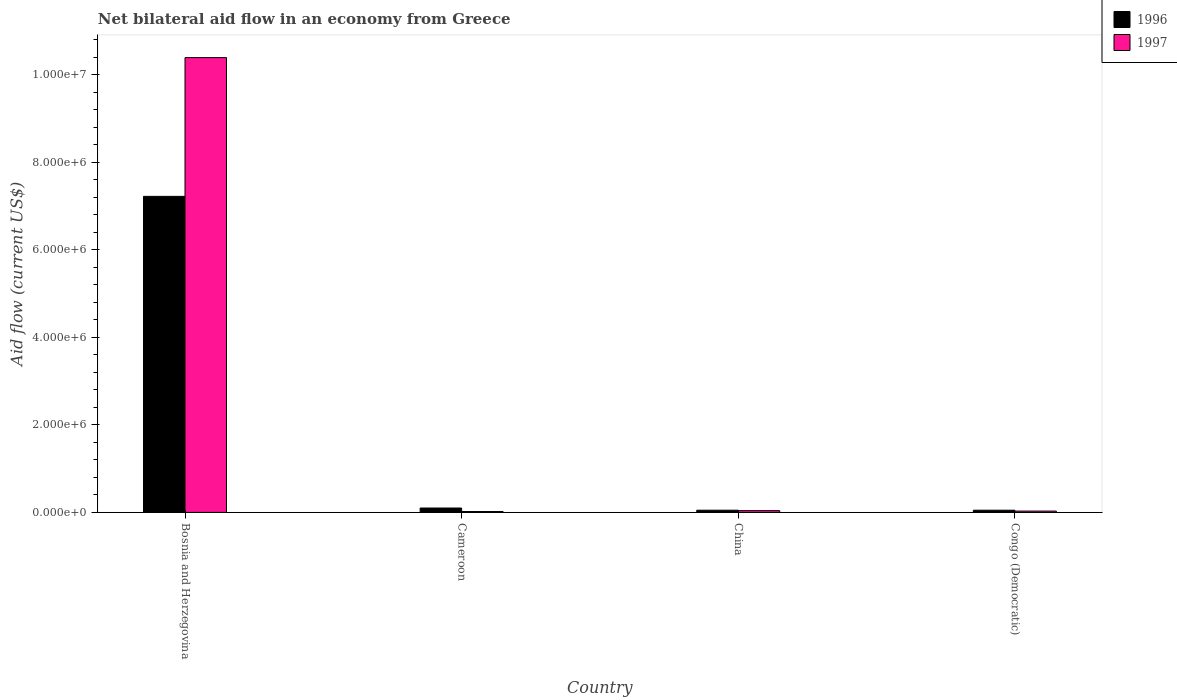How many different coloured bars are there?
Provide a short and direct response. 2. How many groups of bars are there?
Give a very brief answer. 4. How many bars are there on the 1st tick from the left?
Provide a succinct answer. 2. What is the label of the 1st group of bars from the left?
Provide a short and direct response. Bosnia and Herzegovina. What is the net bilateral aid flow in 1996 in China?
Keep it short and to the point. 5.00e+04. Across all countries, what is the maximum net bilateral aid flow in 1996?
Provide a succinct answer. 7.22e+06. In which country was the net bilateral aid flow in 1997 maximum?
Your answer should be compact. Bosnia and Herzegovina. In which country was the net bilateral aid flow in 1997 minimum?
Your answer should be compact. Cameroon. What is the total net bilateral aid flow in 1997 in the graph?
Your answer should be very brief. 1.05e+07. What is the difference between the net bilateral aid flow in 1997 in China and that in Congo (Democratic)?
Your response must be concise. 10000. What is the average net bilateral aid flow in 1997 per country?
Give a very brief answer. 2.62e+06. In how many countries, is the net bilateral aid flow in 1996 greater than 1200000 US$?
Give a very brief answer. 1. What is the ratio of the net bilateral aid flow in 1997 in China to that in Congo (Democratic)?
Offer a very short reply. 1.33. What is the difference between the highest and the second highest net bilateral aid flow in 1997?
Make the answer very short. 1.04e+07. What is the difference between the highest and the lowest net bilateral aid flow in 1997?
Ensure brevity in your answer.  1.04e+07. In how many countries, is the net bilateral aid flow in 1996 greater than the average net bilateral aid flow in 1996 taken over all countries?
Your answer should be compact. 1. Is the sum of the net bilateral aid flow in 1996 in Bosnia and Herzegovina and Cameroon greater than the maximum net bilateral aid flow in 1997 across all countries?
Your answer should be compact. No. What does the 2nd bar from the left in China represents?
Offer a very short reply. 1997. How many bars are there?
Your response must be concise. 8. Are all the bars in the graph horizontal?
Provide a succinct answer. No. How many countries are there in the graph?
Offer a very short reply. 4. Does the graph contain any zero values?
Your response must be concise. No. Where does the legend appear in the graph?
Offer a very short reply. Top right. What is the title of the graph?
Your answer should be compact. Net bilateral aid flow in an economy from Greece. What is the label or title of the Y-axis?
Make the answer very short. Aid flow (current US$). What is the Aid flow (current US$) in 1996 in Bosnia and Herzegovina?
Your answer should be compact. 7.22e+06. What is the Aid flow (current US$) in 1997 in Bosnia and Herzegovina?
Your answer should be compact. 1.04e+07. What is the Aid flow (current US$) in 1996 in Cameroon?
Your answer should be compact. 1.00e+05. What is the Aid flow (current US$) of 1996 in China?
Give a very brief answer. 5.00e+04. What is the Aid flow (current US$) of 1996 in Congo (Democratic)?
Provide a succinct answer. 5.00e+04. What is the Aid flow (current US$) in 1997 in Congo (Democratic)?
Offer a very short reply. 3.00e+04. Across all countries, what is the maximum Aid flow (current US$) of 1996?
Offer a terse response. 7.22e+06. Across all countries, what is the maximum Aid flow (current US$) in 1997?
Provide a short and direct response. 1.04e+07. Across all countries, what is the minimum Aid flow (current US$) in 1997?
Make the answer very short. 2.00e+04. What is the total Aid flow (current US$) of 1996 in the graph?
Provide a succinct answer. 7.42e+06. What is the total Aid flow (current US$) of 1997 in the graph?
Your answer should be very brief. 1.05e+07. What is the difference between the Aid flow (current US$) in 1996 in Bosnia and Herzegovina and that in Cameroon?
Give a very brief answer. 7.12e+06. What is the difference between the Aid flow (current US$) of 1997 in Bosnia and Herzegovina and that in Cameroon?
Provide a short and direct response. 1.04e+07. What is the difference between the Aid flow (current US$) of 1996 in Bosnia and Herzegovina and that in China?
Offer a terse response. 7.17e+06. What is the difference between the Aid flow (current US$) of 1997 in Bosnia and Herzegovina and that in China?
Your response must be concise. 1.04e+07. What is the difference between the Aid flow (current US$) in 1996 in Bosnia and Herzegovina and that in Congo (Democratic)?
Ensure brevity in your answer.  7.17e+06. What is the difference between the Aid flow (current US$) in 1997 in Bosnia and Herzegovina and that in Congo (Democratic)?
Provide a short and direct response. 1.04e+07. What is the difference between the Aid flow (current US$) in 1997 in Cameroon and that in China?
Ensure brevity in your answer.  -2.00e+04. What is the difference between the Aid flow (current US$) of 1997 in Cameroon and that in Congo (Democratic)?
Offer a terse response. -10000. What is the difference between the Aid flow (current US$) of 1996 in Bosnia and Herzegovina and the Aid flow (current US$) of 1997 in Cameroon?
Your answer should be compact. 7.20e+06. What is the difference between the Aid flow (current US$) of 1996 in Bosnia and Herzegovina and the Aid flow (current US$) of 1997 in China?
Offer a very short reply. 7.18e+06. What is the difference between the Aid flow (current US$) of 1996 in Bosnia and Herzegovina and the Aid flow (current US$) of 1997 in Congo (Democratic)?
Provide a short and direct response. 7.19e+06. What is the difference between the Aid flow (current US$) of 1996 in Cameroon and the Aid flow (current US$) of 1997 in China?
Offer a terse response. 6.00e+04. What is the difference between the Aid flow (current US$) of 1996 in Cameroon and the Aid flow (current US$) of 1997 in Congo (Democratic)?
Your response must be concise. 7.00e+04. What is the average Aid flow (current US$) of 1996 per country?
Keep it short and to the point. 1.86e+06. What is the average Aid flow (current US$) in 1997 per country?
Give a very brief answer. 2.62e+06. What is the difference between the Aid flow (current US$) of 1996 and Aid flow (current US$) of 1997 in Bosnia and Herzegovina?
Make the answer very short. -3.17e+06. What is the ratio of the Aid flow (current US$) in 1996 in Bosnia and Herzegovina to that in Cameroon?
Ensure brevity in your answer.  72.2. What is the ratio of the Aid flow (current US$) of 1997 in Bosnia and Herzegovina to that in Cameroon?
Provide a succinct answer. 519.5. What is the ratio of the Aid flow (current US$) in 1996 in Bosnia and Herzegovina to that in China?
Provide a short and direct response. 144.4. What is the ratio of the Aid flow (current US$) in 1997 in Bosnia and Herzegovina to that in China?
Your answer should be very brief. 259.75. What is the ratio of the Aid flow (current US$) in 1996 in Bosnia and Herzegovina to that in Congo (Democratic)?
Your response must be concise. 144.4. What is the ratio of the Aid flow (current US$) of 1997 in Bosnia and Herzegovina to that in Congo (Democratic)?
Offer a very short reply. 346.33. What is the ratio of the Aid flow (current US$) of 1996 in Cameroon to that in China?
Offer a terse response. 2. What is the ratio of the Aid flow (current US$) of 1997 in China to that in Congo (Democratic)?
Your answer should be very brief. 1.33. What is the difference between the highest and the second highest Aid flow (current US$) of 1996?
Keep it short and to the point. 7.12e+06. What is the difference between the highest and the second highest Aid flow (current US$) in 1997?
Give a very brief answer. 1.04e+07. What is the difference between the highest and the lowest Aid flow (current US$) of 1996?
Keep it short and to the point. 7.17e+06. What is the difference between the highest and the lowest Aid flow (current US$) of 1997?
Make the answer very short. 1.04e+07. 